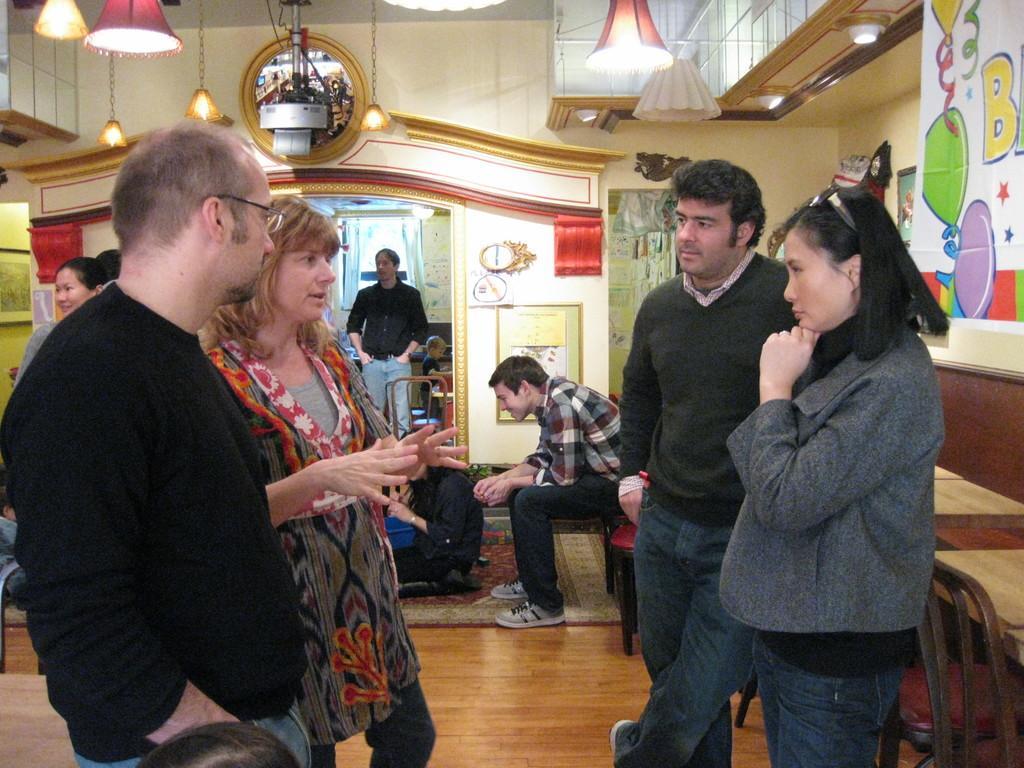In one or two sentences, can you explain what this image depicts? In this picture we can see so many people are talking to each other, some are sitting and some are standing. 